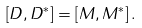Convert formula to latex. <formula><loc_0><loc_0><loc_500><loc_500>\left [ D , D ^ { \ast } \right ] = \left [ M , M ^ { \ast } \right ] .</formula> 